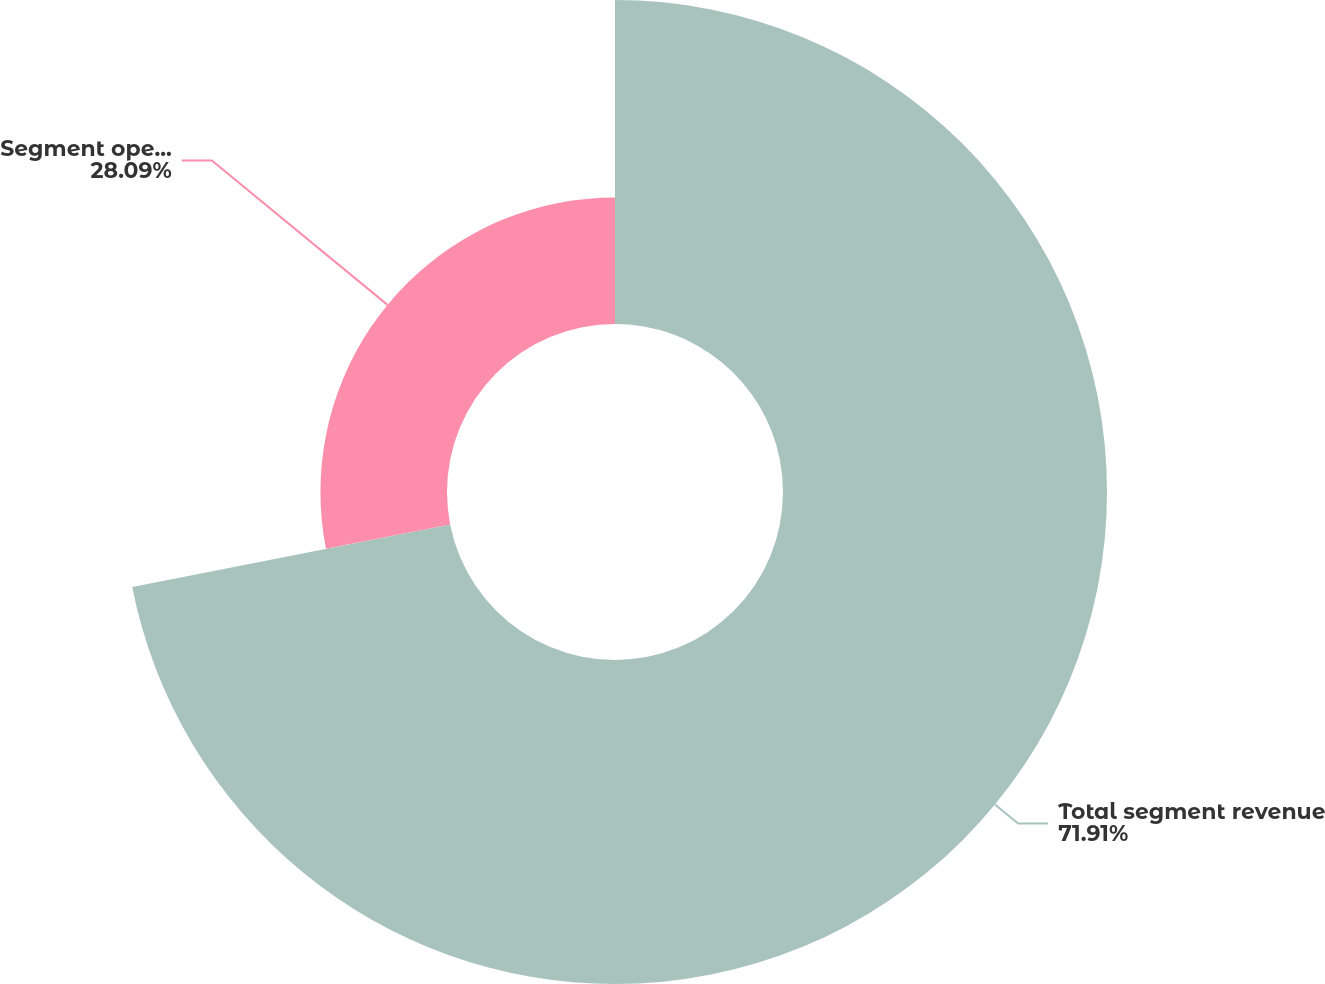<chart> <loc_0><loc_0><loc_500><loc_500><pie_chart><fcel>Total segment revenue<fcel>Segment operating income<nl><fcel>71.91%<fcel>28.09%<nl></chart> 